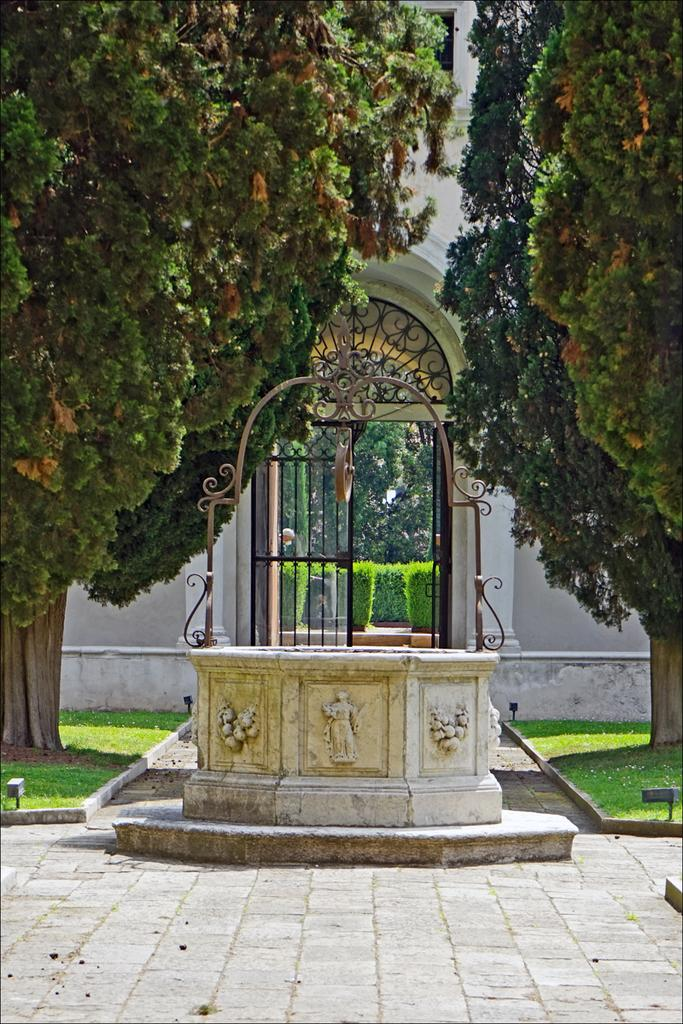What type of path is visible in the image? There is a path in the image, but the specific type of path is not mentioned. What is the water well with a pulley used for in the image? The water well with a pulley is used for drawing water in the image. What type of vegetation is present in the image? There are trees in the image. What type of ground cover is visible in the image? There is grass in the image. What type of calculator is being used by the group in the image? There is no calculator or group present in the image. What direction is the front of the water well facing in the image? The water well does not have a front or back, as it is a stationary object. 